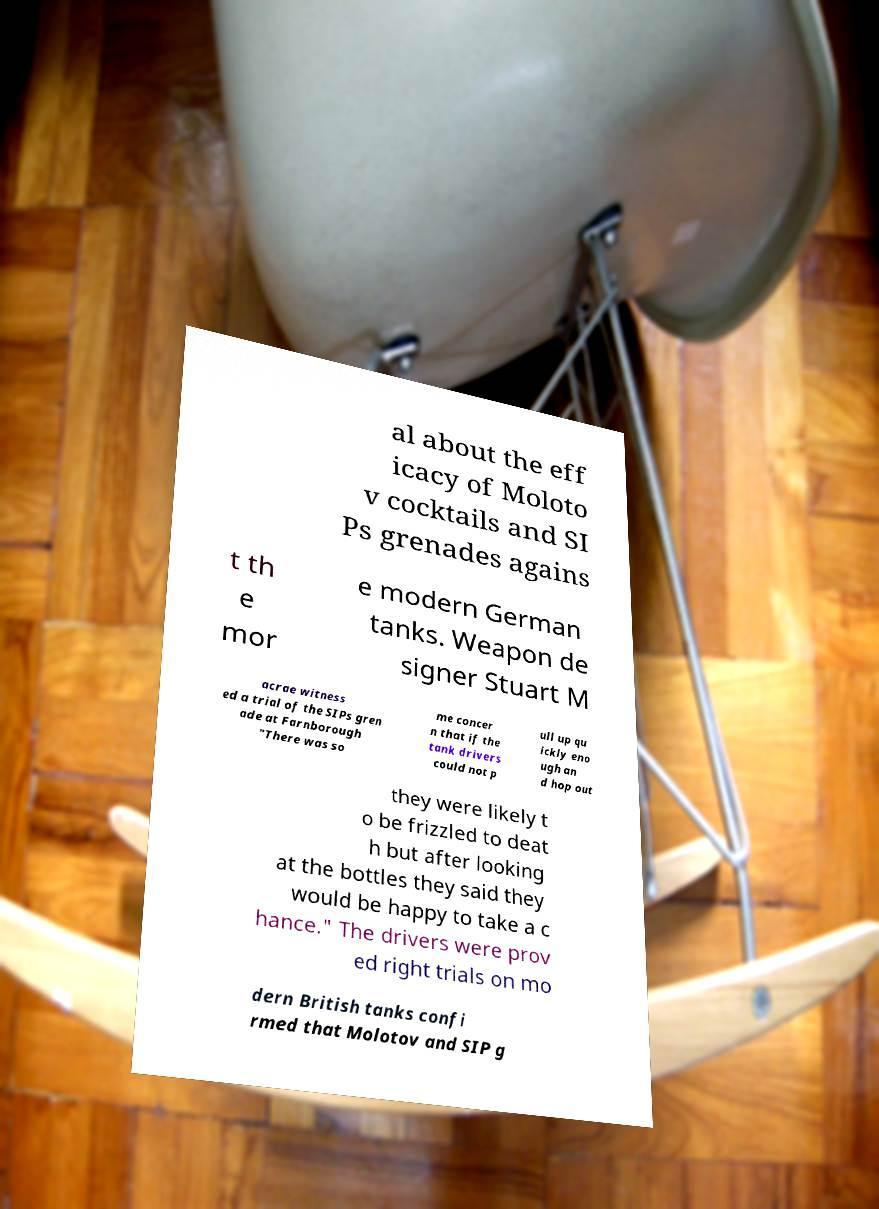Can you accurately transcribe the text from the provided image for me? al about the eff icacy of Moloto v cocktails and SI Ps grenades agains t th e mor e modern German tanks. Weapon de signer Stuart M acrae witness ed a trial of the SIPs gren ade at Farnborough "There was so me concer n that if the tank drivers could not p ull up qu ickly eno ugh an d hop out they were likely t o be frizzled to deat h but after looking at the bottles they said they would be happy to take a c hance." The drivers were prov ed right trials on mo dern British tanks confi rmed that Molotov and SIP g 